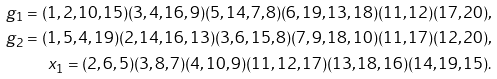<formula> <loc_0><loc_0><loc_500><loc_500>g _ { 1 } = ( 1 , 2 , 1 0 , 1 5 ) ( 3 , 4 , 1 6 , 9 ) ( 5 , 1 4 , 7 , 8 ) ( 6 , 1 9 , 1 3 , 1 8 ) ( 1 1 , 1 2 ) ( 1 7 , 2 0 ) , \\ g _ { 2 } = ( 1 , 5 , 4 , 1 9 ) ( 2 , 1 4 , 1 6 , 1 3 ) ( 3 , 6 , 1 5 , 8 ) ( 7 , 9 , 1 8 , 1 0 ) ( 1 1 , 1 7 ) ( 1 2 , 2 0 ) , \\ x _ { 1 } = ( 2 , 6 , 5 ) ( 3 , 8 , 7 ) ( 4 , 1 0 , 9 ) ( 1 1 , 1 2 , 1 7 ) ( 1 3 , 1 8 , 1 6 ) ( 1 4 , 1 9 , 1 5 ) .</formula> 